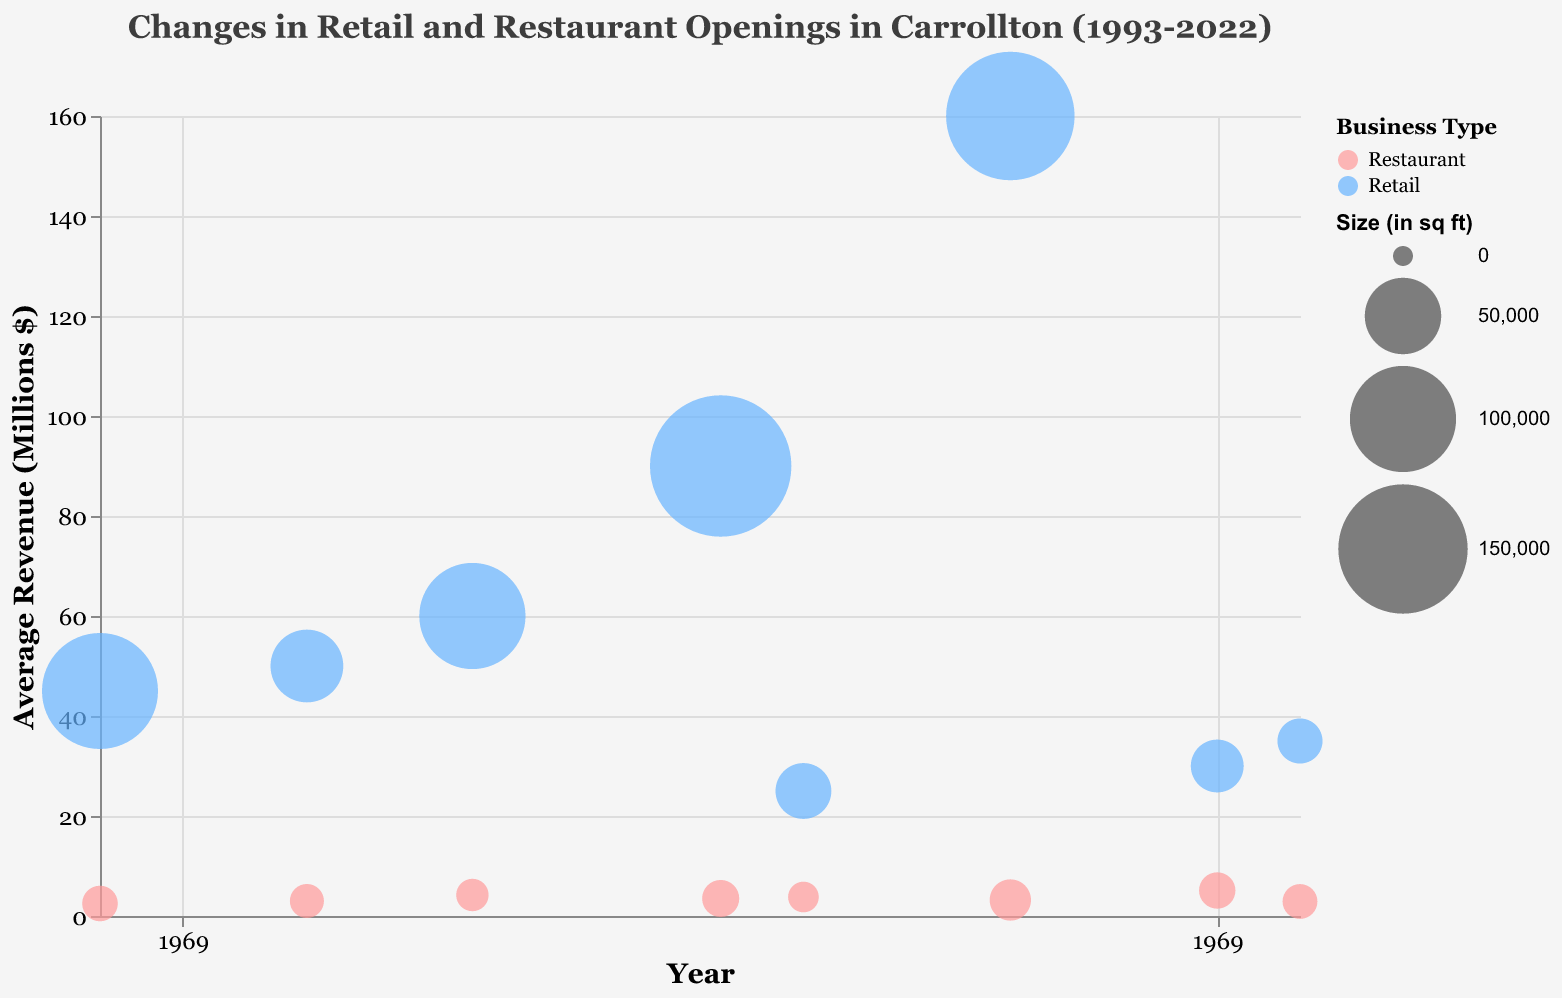How frequently are restaurant businesses depicted in the chart as compared to retail businesses from 1993 to 2022? By counting the number of bubbles of each color (restaurants in pink and retail in blue), one can determine that there are more restaurant businesses than retail businesses depicted in the chart.
Answer: More restaurants What is the title of the chart? The title is displayed at the top of the chart.
Answer: "Changes in Retail and Restaurant Openings in Carrollton (1993-2022)" Which year saw the maximum individual revenue for a retail establishment and what was the amount? The year with the highest value on the Y-axis for a retail business based on the size of the bubble is 2015, and the entity is Costco with $160 million.
Answer: 2015, $160 million What was the average revenue of restaurant businesses in the year 2020? Locate the two restaurant bubbles for the year 2020 on the X-axis and average their revenue values: (5.1 + 5.1)/2 = 5.1 million.
Answer: 5.1 million How many total retail businesses opened in the year 2002? Find the bubbles for retail businesses in 2002 on the X-axis and sum the 'Openings' values for them: 2 (Kroger).
Answer: 2 In which year, did restaurants have a higher average revenue than retail businesses? Compare the average revenue for both business types for each year; in 2020, restaurants (5.1 million) have a higher average revenue compared to retail (30 million/3 results in 10 million).
Answer: None Which has a higher revenue, the smallest or the largest bubble on the chart? Comparing the smallest bubble ('2.5' millions) and largest bubble ('160' millions) it is clear that the largest bubble's business has a higher revenue.
Answer: Largest bubble Which restaurant had the highest average revenue, and what was the value? By examining the Y-axis among restaurant entities and finding the highest bubble, it shows Heritage Pizza and Taproom in 2020 with 5.1 million.
Answer: Heritage Pizza and Taproom, 5.1 million 